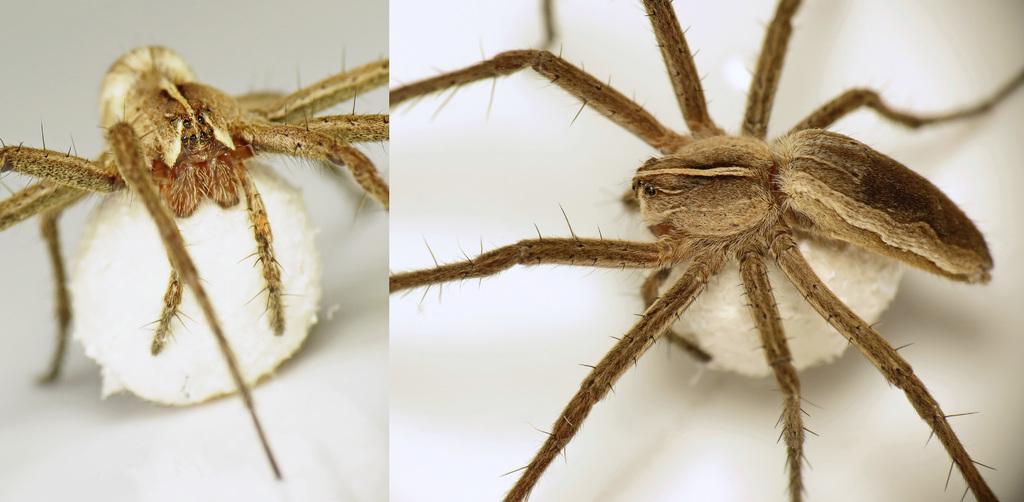Could you give a brief overview of what you see in this image? It is a collage picture. On the left side of the image, we can see a spider on a white color object. And on the right side of the image, we can see one more spider on a white color object. And we can see the white colored background. 